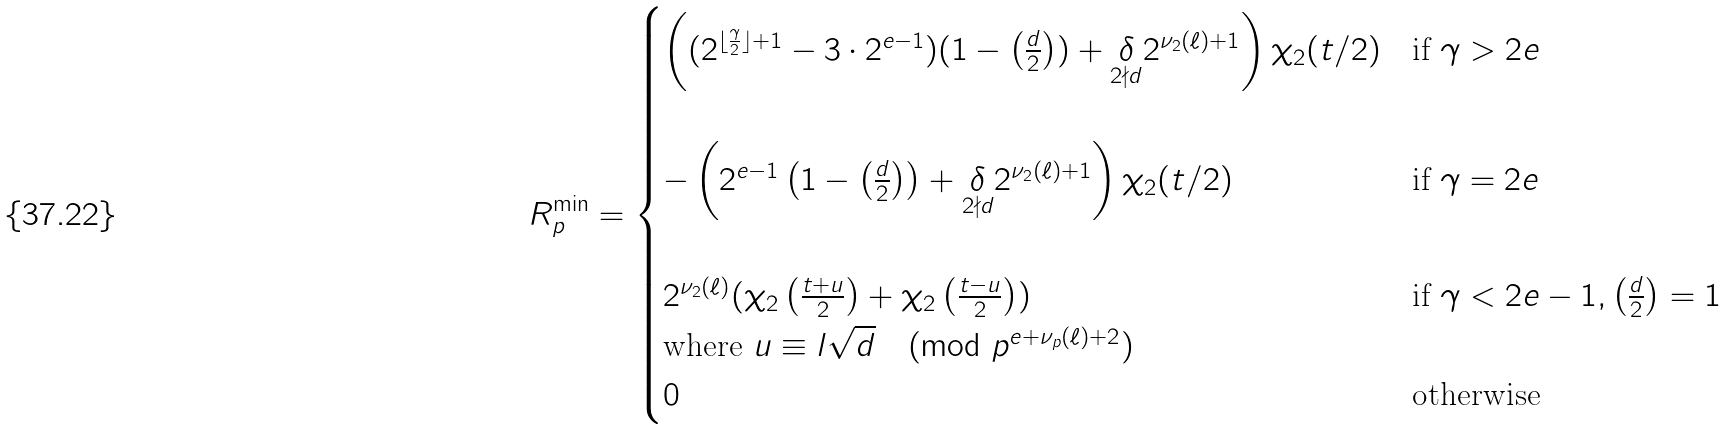<formula> <loc_0><loc_0><loc_500><loc_500>R _ { p } ^ { \min } = \begin{cases} \left ( ( 2 ^ { \lfloor \frac { \gamma } { 2 } \rfloor + 1 } - 3 \cdot 2 ^ { e - 1 } ) ( 1 - \left ( \frac { d } { 2 } \right ) ) + \underset { 2 \nmid d } { \delta } 2 ^ { \nu _ { 2 } ( \ell ) + 1 } \right ) \chi _ { 2 } ( t / 2 ) & \text {if } \gamma > 2 e \\ \\ - \left ( 2 ^ { e - 1 } \left ( 1 - \left ( \frac { d } { 2 } \right ) \right ) + \underset { 2 \nmid d } { \delta } 2 ^ { \nu _ { 2 } ( \ell ) + 1 } \right ) \chi _ { 2 } ( t / 2 ) & \text {if } \gamma = 2 e \\ \\ 2 ^ { \nu _ { 2 } ( \ell ) } ( \chi _ { 2 } \left ( \frac { t + u } { 2 } \right ) + \chi _ { 2 } \left ( \frac { t - u } { 2 } \right ) ) & \text {if } \gamma < 2 e - 1 , \left ( \frac { d } { 2 } \right ) = 1 \\ \text {where } u \equiv l \sqrt { d } \pmod { p ^ { e + \nu _ { p } ( \ell ) + 2 } } \\ 0 & \text {otherwise} \end{cases}</formula> 